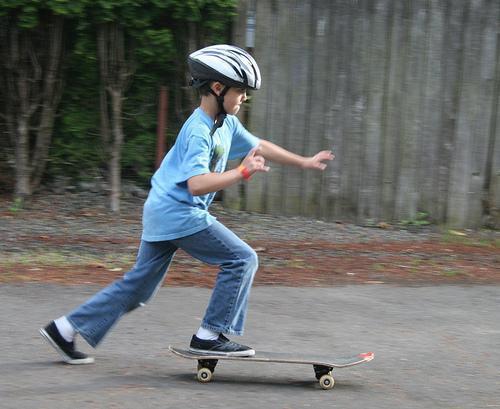How many wheels can be seen?
Give a very brief answer. 2. How many feet are on the skateboard?
Give a very brief answer. 1. 